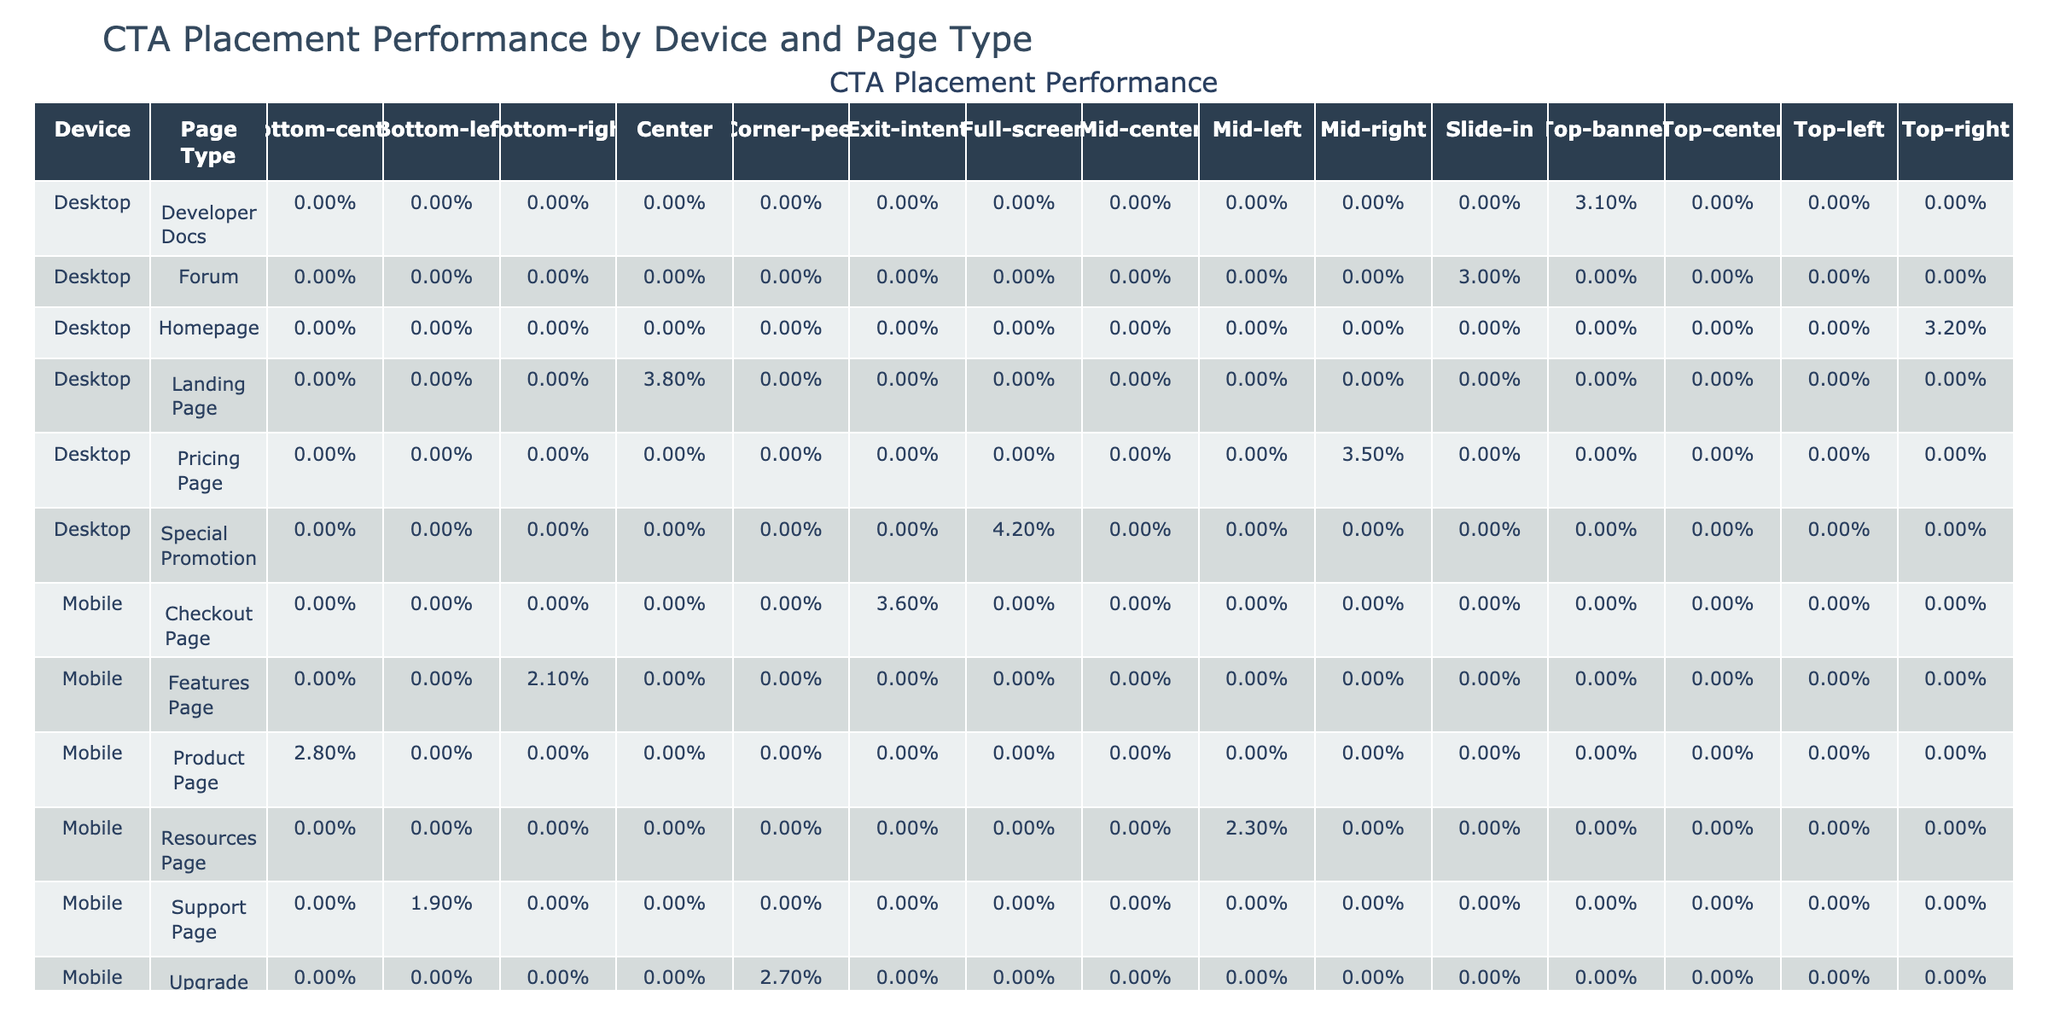What is the highest conversion rate among the placements? By examining the table, we determine the highest conversion rate by scanning through the "Conversion Rate" values. The placement "Full-screen" has a conversion rate of 4.2%, which is the maximum in the table.
Answer: 4.2% Which placement had the most clicks on mobile devices? Looking at the mobile device row values in the table, the placement "Exit-intent" has 1440 clicks, which is the highest when compared to other placements for mobile.
Answer: Exit-intent What is the average conversion rate for desktop placements? To calculate the average for desktop placements, we sum the conversion rates for "Top-right" (3.2%), "Mid-right" (3.5%), "Center" (3.8%), "Top-banner" (3.1%), and "Slide-in" (3.0%). Adding these gives 3.2 + 3.5 + 3.8 + 3.1 + 3.0 = 16.6%. Dividing by 5 placements gives an average of 3.32%.
Answer: 3.32% Is the "Bottom-left" placement more effective than the "Top-left" placement? Comparing the conversion rates, "Bottom-left" has a conversion rate of 1.9% while "Top-left" has 2.5%. Since 1.9% is less than 2.5%, "Bottom-left" is not more effective than "Top-left".
Answer: No What is the total number of impressions for all placements on tablet devices? To find the total impressions for tablet devices, we add the impressions for placements on tablets: "Top-left" (35000), "Top-center" (35000), and "Mid-left" (35000). Summing these gives 35000 + 35000 + 35000 = 105000 impressions.
Answer: 105000 Which placement has the lowest conversion rate on product pages? The table shows that "Bottom-center" is the only placement associated with product pages, and it has a conversion rate of 2.8%, making it the lowest by default since it is the only one listed.
Answer: 2.8% Does "Claim Your Spot" have a higher conversion rate than "Join for Free"? Checking the conversion rates, "Claim Your Spot" has a conversion rate of 3.8%, while "Join for Free" has 3.5%. Since 3.8% is greater than 3.5%, the statement is true.
Answer: Yes What is the difference in conversion rates between the highest and lowest performing placements on mobile devices? The highest mobile conversion rate is for "Exit-intent" at 3.6% and the lowest is "Bottom-right" at 2.1%. The difference is calculated as 3.6% - 2.1% = 1.5%.
Answer: 1.5% 